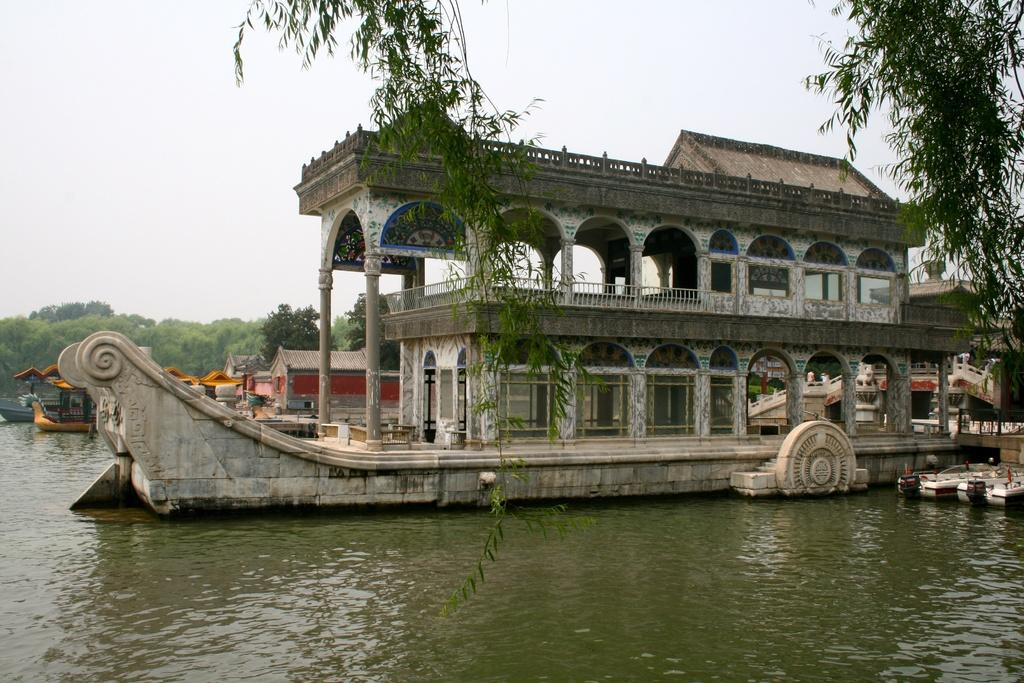What is in the water in the image? There are boats in the water in the image. What can be seen in the background of the image? Buildings, windows, fences, and trees are present in the background. What is visible in the sky in the image? Clouds are visible in the sky in the image. Who is the creator of the rock in the image? There is no rock present in the image. How many cakes are visible in the image? There are no cakes present in the image. 